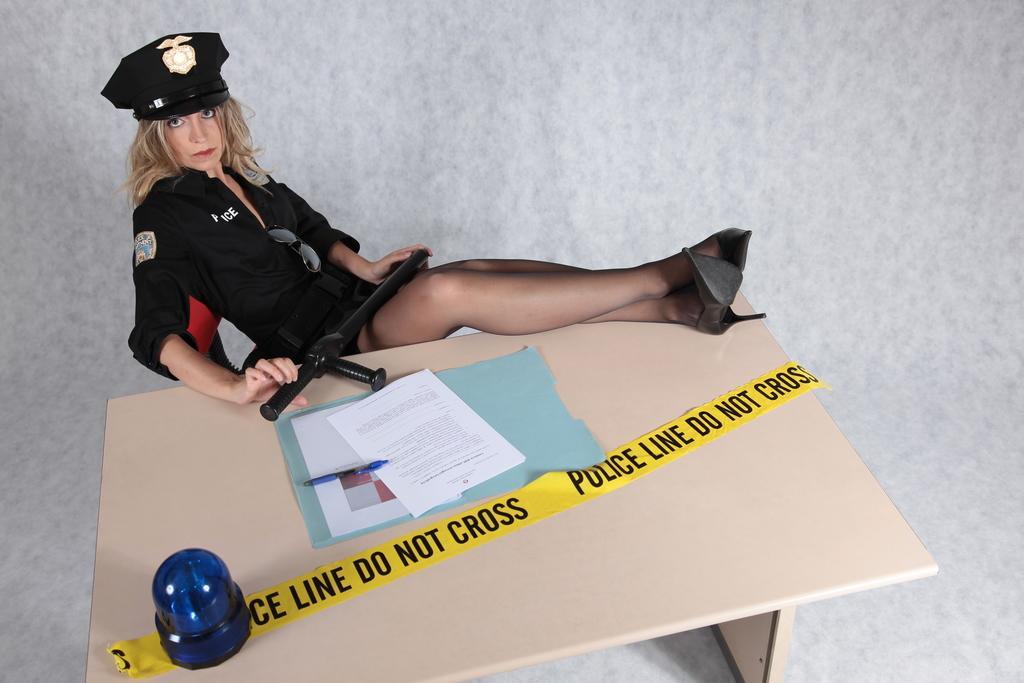Please provide a concise description of this image. As we can see in the image there is a woman sitting on chair and there is a table. On table there is a paper and pen. 